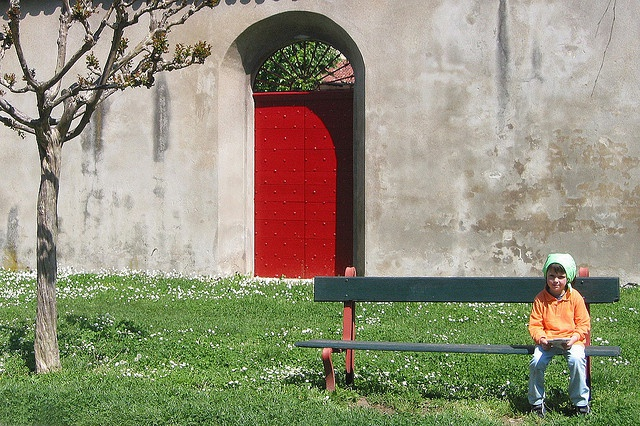Describe the objects in this image and their specific colors. I can see bench in black, purple, and gray tones and people in black, white, gray, and tan tones in this image. 